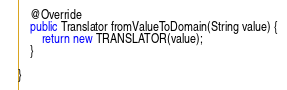<code> <loc_0><loc_0><loc_500><loc_500><_Java_>
	@Override
	public Translator fromValueToDomain(String value) {
		return new TRANSLATOR(value);
	}

}
</code> 